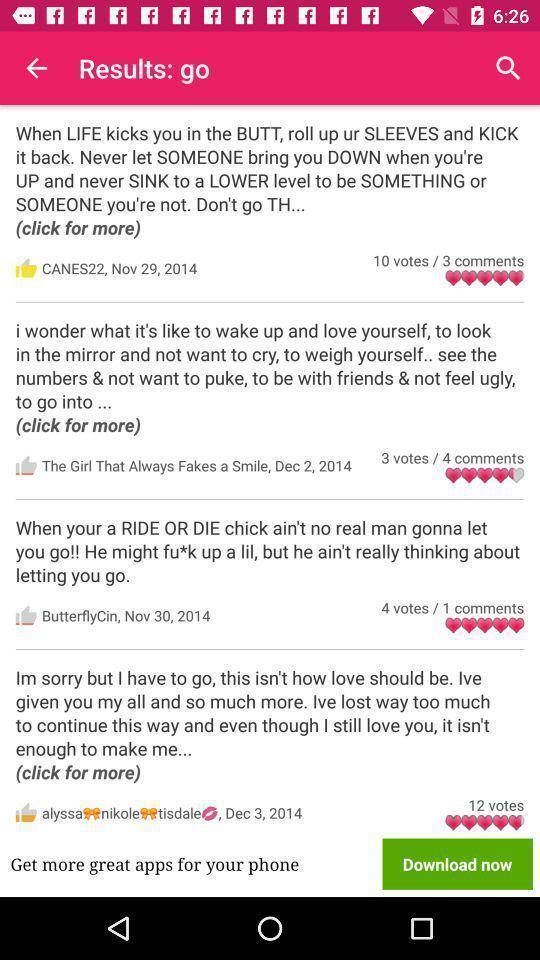Explain the elements present in this screenshot. Screen shows list of reviews. 